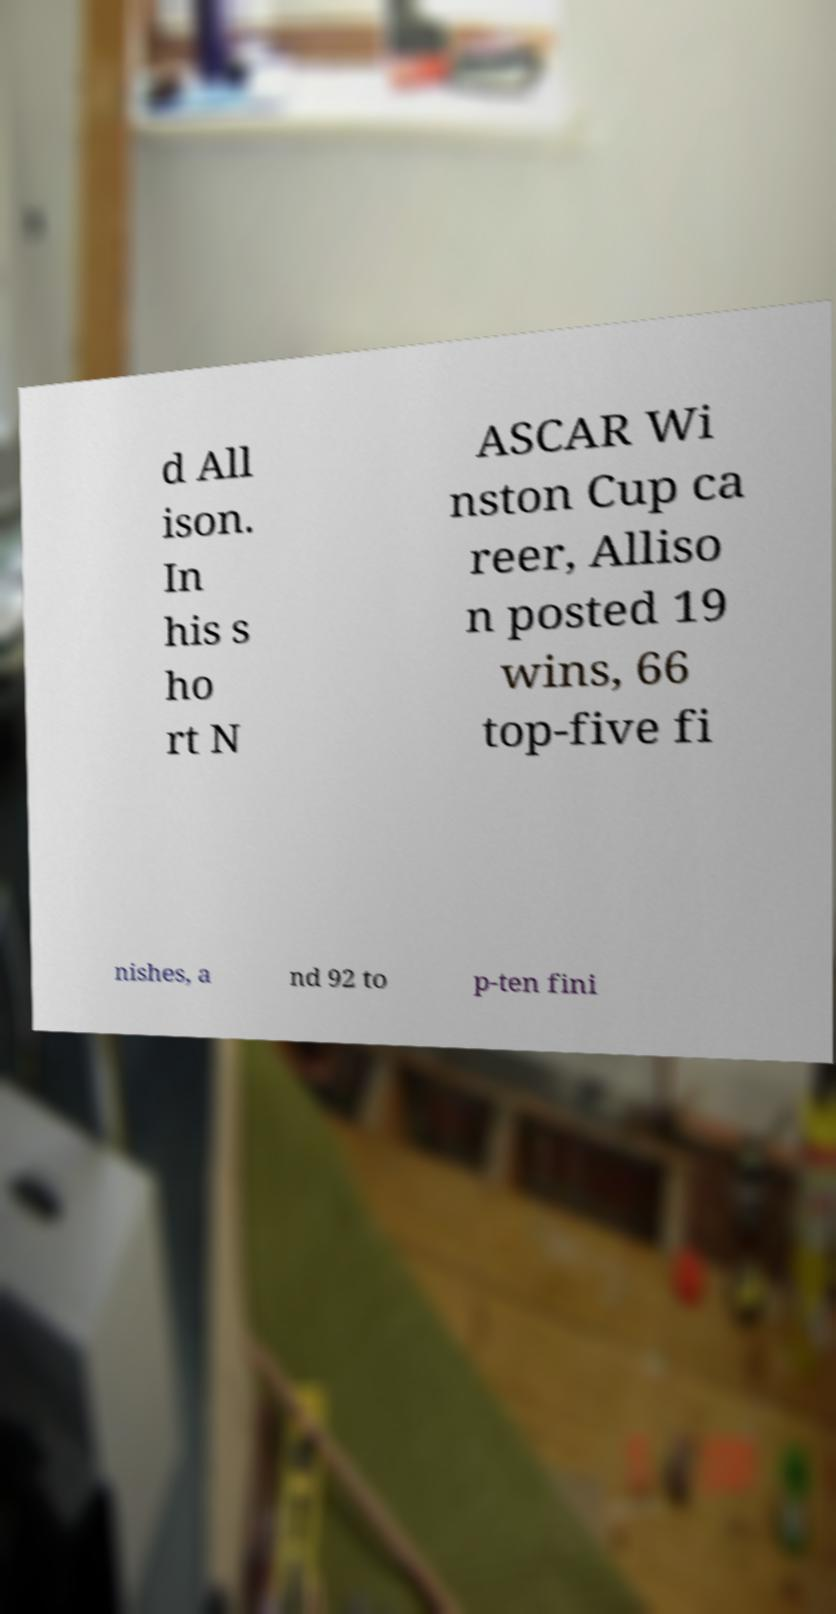Could you extract and type out the text from this image? d All ison. In his s ho rt N ASCAR Wi nston Cup ca reer, Alliso n posted 19 wins, 66 top-five fi nishes, a nd 92 to p-ten fini 